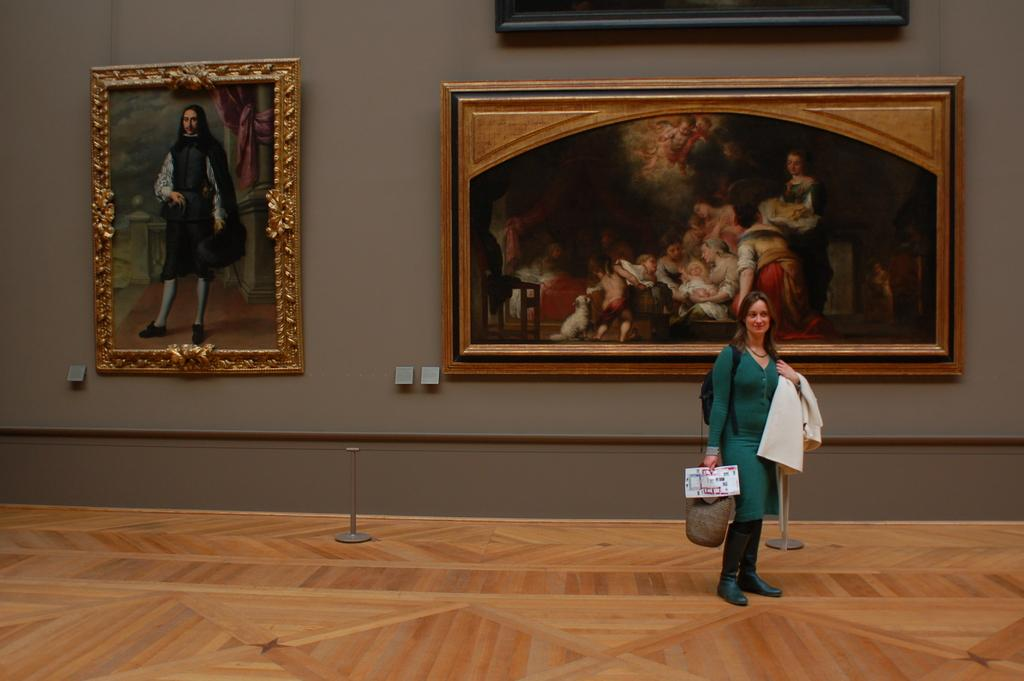Who is present in the image? There is a lady in the image. What is the lady holding in the image? The lady is holding a bag and a jacket. What can be seen in the background of the image? There are poles and a wall with frames visible in the image. What type of lunch is the lady eating in the image? There is no lunch present in the image; the lady is holding a bag and a jacket. What kind of humor can be seen in the frames on the wall? There is no humor depicted in the frames on the wall; they are simply frames on a wall. 